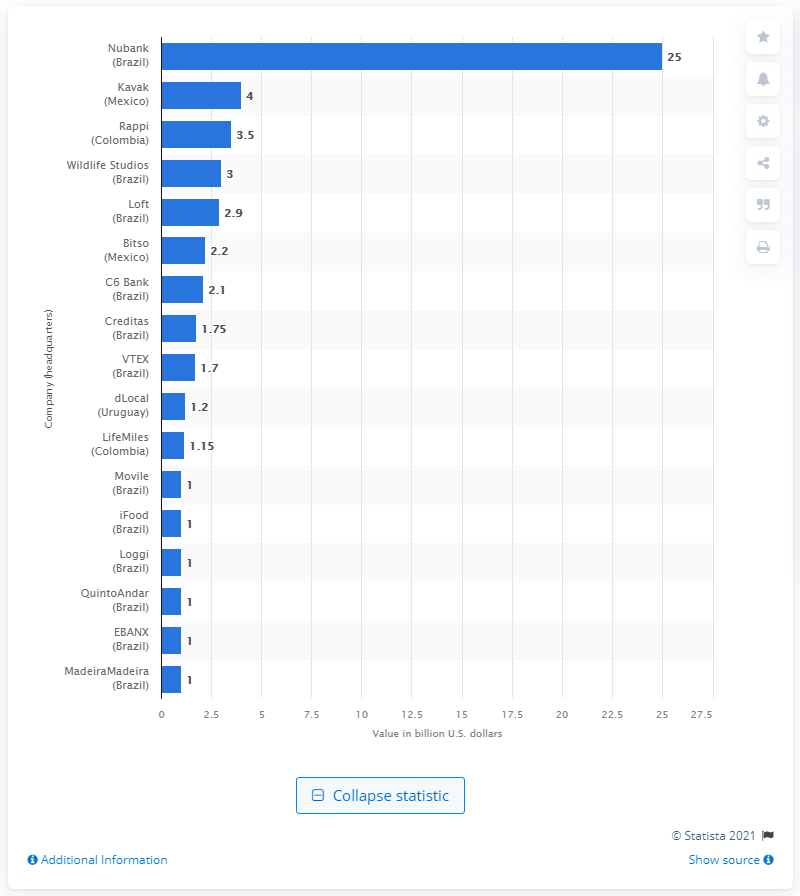List a handful of essential elements in this visual. Nubank's market capitalization value was approximately 25.. The value of a unicorn is 25... 